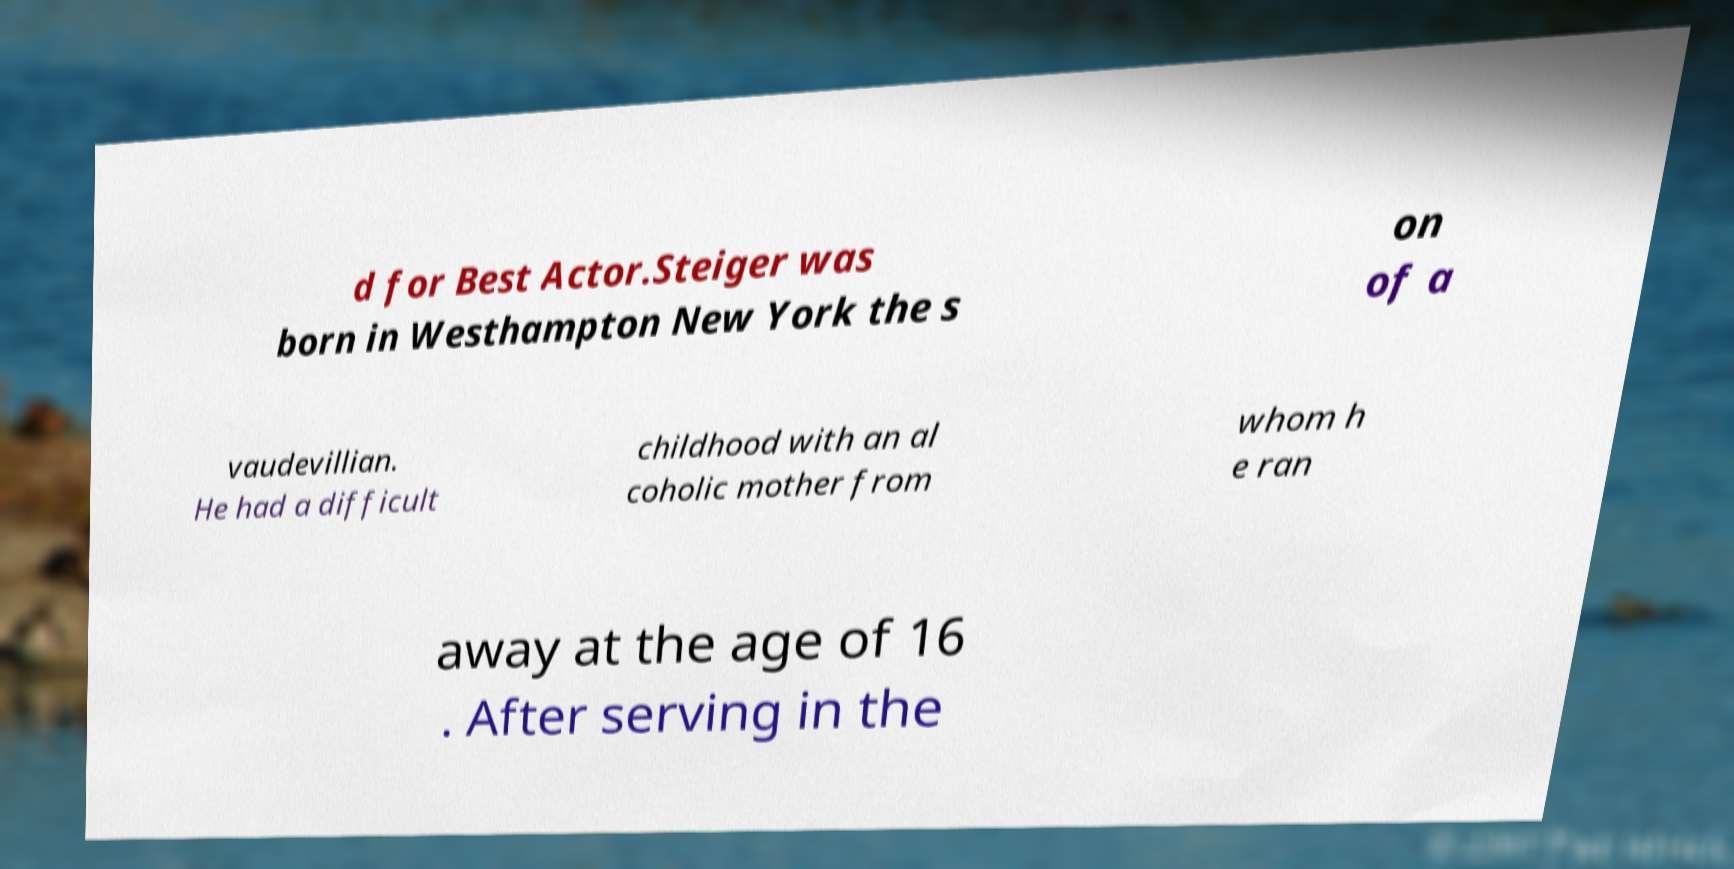Can you accurately transcribe the text from the provided image for me? d for Best Actor.Steiger was born in Westhampton New York the s on of a vaudevillian. He had a difficult childhood with an al coholic mother from whom h e ran away at the age of 16 . After serving in the 